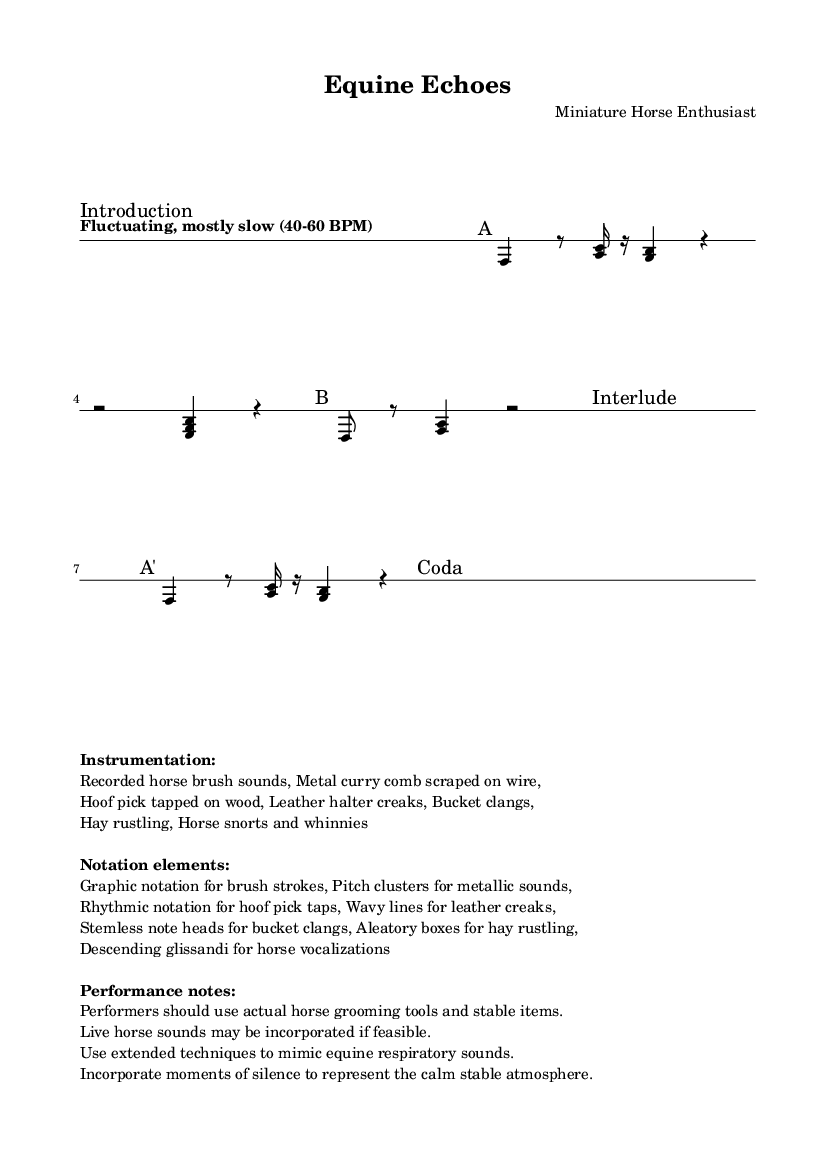What is the tempo marking for this piece? The tempo marking indicates a "Fluctuating, mostly slow" tempo with a range from 40 to 60 BPM. This can be found at the beginning of the score under the tempo indication.
Answer: Fluctuating, mostly slow (40-60 BPM) What time signature is used in Section B? Section B is marked with a time signature of 3/4, as indicated at the beginning of that section. This means there are three beats in each measure, which guides the pacing of the rhythm.
Answer: 3/4 Which section contains the notation for pitch clusters? The notation elements describe "Pitch clusters for metallic sounds." Since this relates to the composition of sound using tools, it can be inferred that this is included throughout the entire piece, especially in the sections where metal sounds are asked to be played.
Answer: Section A How many measures are included in the Interlude section? The Interlude section is indicated with a "s4*5" marking, meaning there are 5 measures of silence (or rest) in this section, signifying a pause or quiet moment in the composition.
Answer: 5 What types of sounds are specified as instrumental sounds in the score? The score lists various recorded sounds for the instrumentation such as "horse brush sounds," "metal curry comb scraped on wire," and others, emphasizing non-traditional instrumental choices that relate directly to the equestrian theme of the piece.
Answer: Recorded horse brush sounds, Metal curry comb scraped on wire, Hoof pick tapped on wood, Leather halter creaks, Bucket clangs, Hay rustling, Horse snorts and whinnies What notation technique is used to represent the sounds of hay rustling? The notation element for hay rustling is described as "Aleatory boxes," indicating that performers are given freedom in how they interpret this sound. The use of aleatory notation suggests variability in performance, capturing the unpredictable nature of actual hay rustling.
Answer: Aleatory boxes 